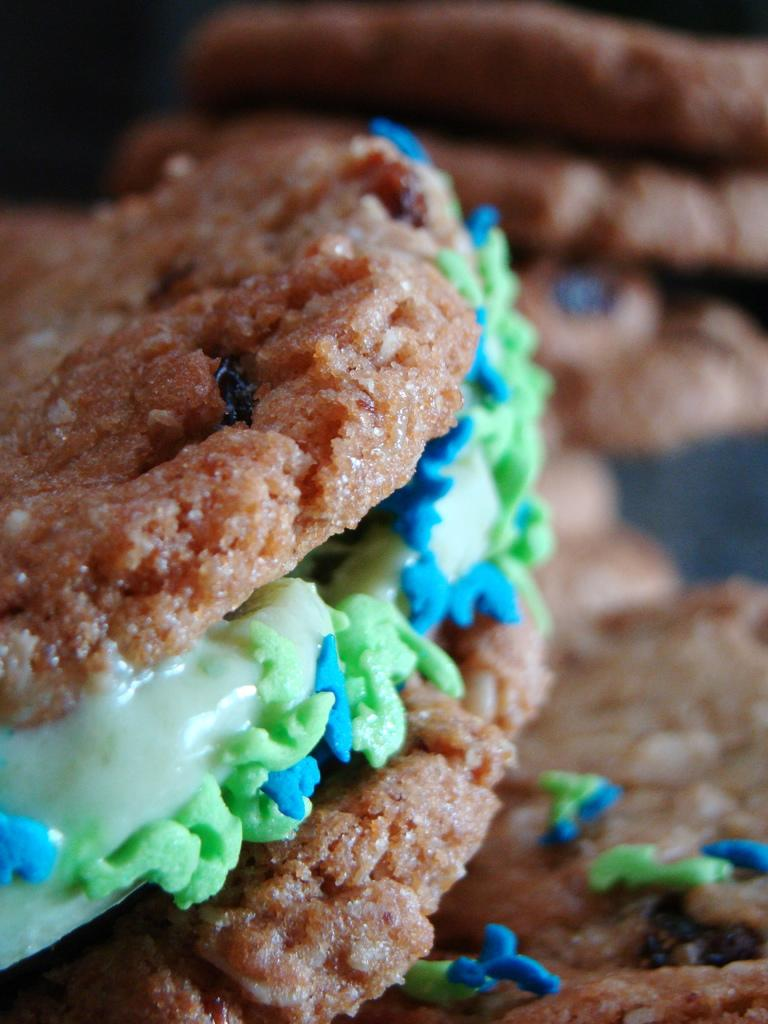What type of food can be seen in the image? There are cookies in the image. Can you describe the cookies in the image? The cookies are visible, but their specific appearance cannot be determined from the provided facts. How many cookies are present in the image? The number of cookies cannot be determined from the provided facts. What type of cork can be seen in the image? There is no cork present in the image; it features cookies. How does the group of people interact with the cookies in the image? There is no mention of a group of people in the image, so their interaction with the cookies cannot be determined. 